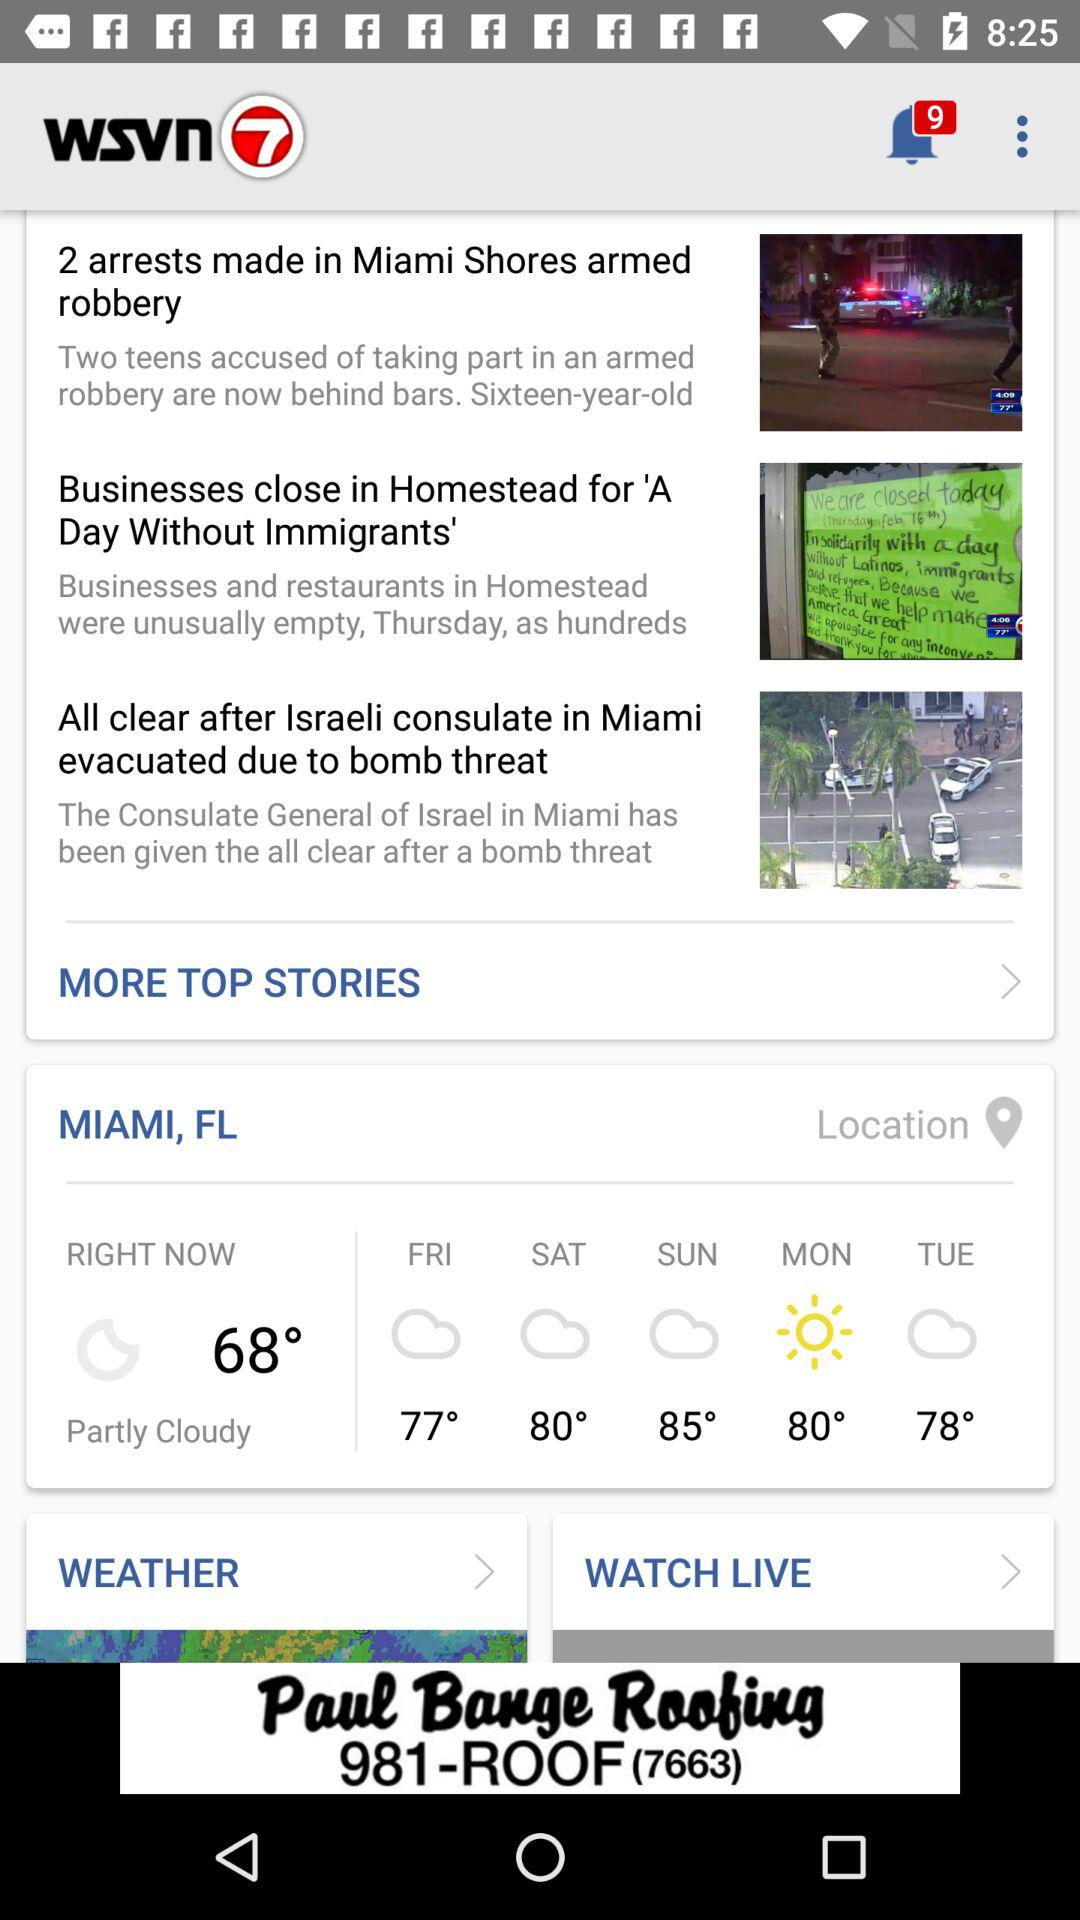How many new notifications are there? There are 9 new notifications. 